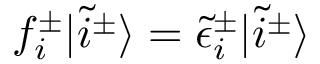Convert formula to latex. <formula><loc_0><loc_0><loc_500><loc_500>\begin{array} { r } { f _ { i } ^ { \pm } | \tilde { i } ^ { \pm } \rangle = \tilde { \epsilon } _ { i } ^ { \pm } | \tilde { i } ^ { \pm } \rangle } \end{array}</formula> 